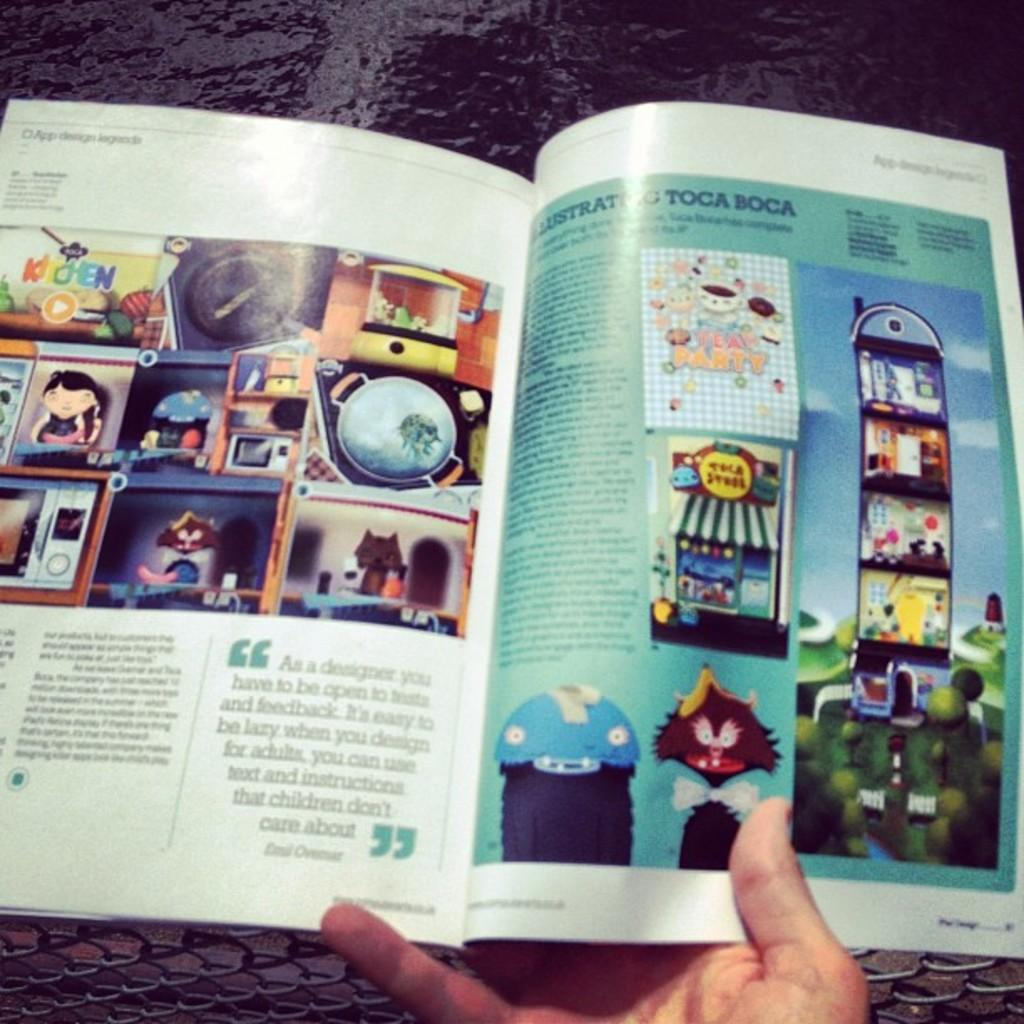What is the person in the image holding? The person is holding a magazine in the image. What type of structure can be seen in the image? There is an iron fencing in the image. What can be seen in the background of the image? Water is visible in the background of the image. How much was the payment for the magazine in the image? There is no information about payment for the magazine in the image. 